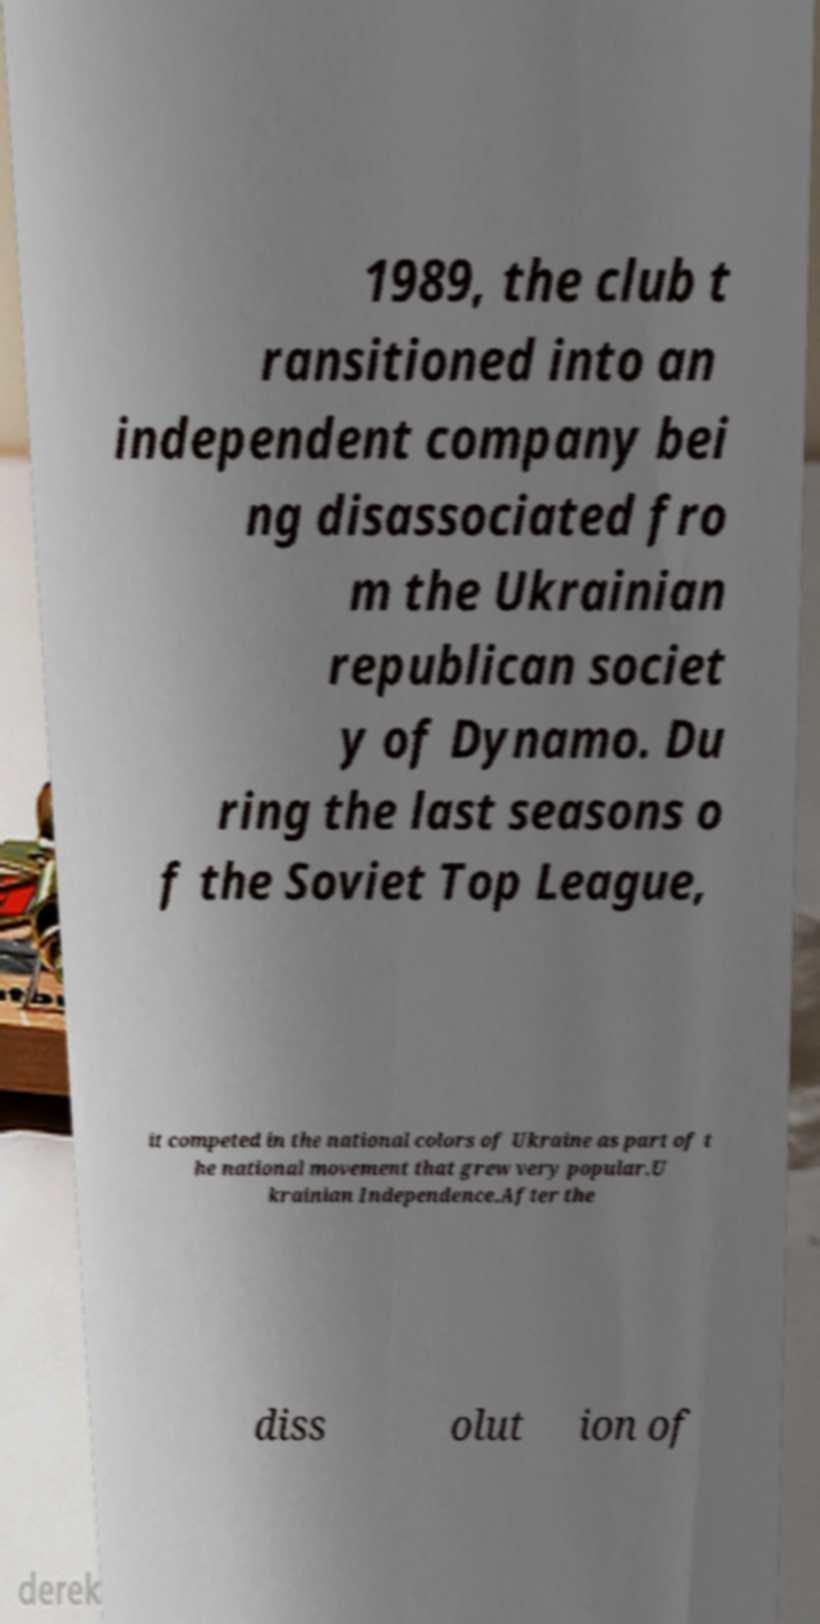Could you assist in decoding the text presented in this image and type it out clearly? 1989, the club t ransitioned into an independent company bei ng disassociated fro m the Ukrainian republican societ y of Dynamo. Du ring the last seasons o f the Soviet Top League, it competed in the national colors of Ukraine as part of t he national movement that grew very popular.U krainian Independence.After the diss olut ion of 